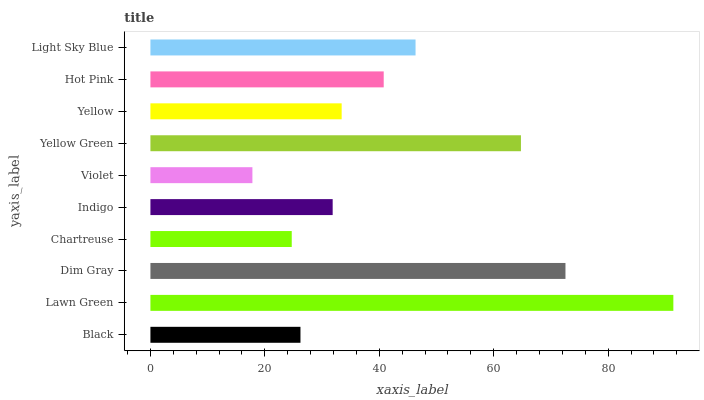Is Violet the minimum?
Answer yes or no. Yes. Is Lawn Green the maximum?
Answer yes or no. Yes. Is Dim Gray the minimum?
Answer yes or no. No. Is Dim Gray the maximum?
Answer yes or no. No. Is Lawn Green greater than Dim Gray?
Answer yes or no. Yes. Is Dim Gray less than Lawn Green?
Answer yes or no. Yes. Is Dim Gray greater than Lawn Green?
Answer yes or no. No. Is Lawn Green less than Dim Gray?
Answer yes or no. No. Is Hot Pink the high median?
Answer yes or no. Yes. Is Yellow the low median?
Answer yes or no. Yes. Is Yellow the high median?
Answer yes or no. No. Is Yellow Green the low median?
Answer yes or no. No. 